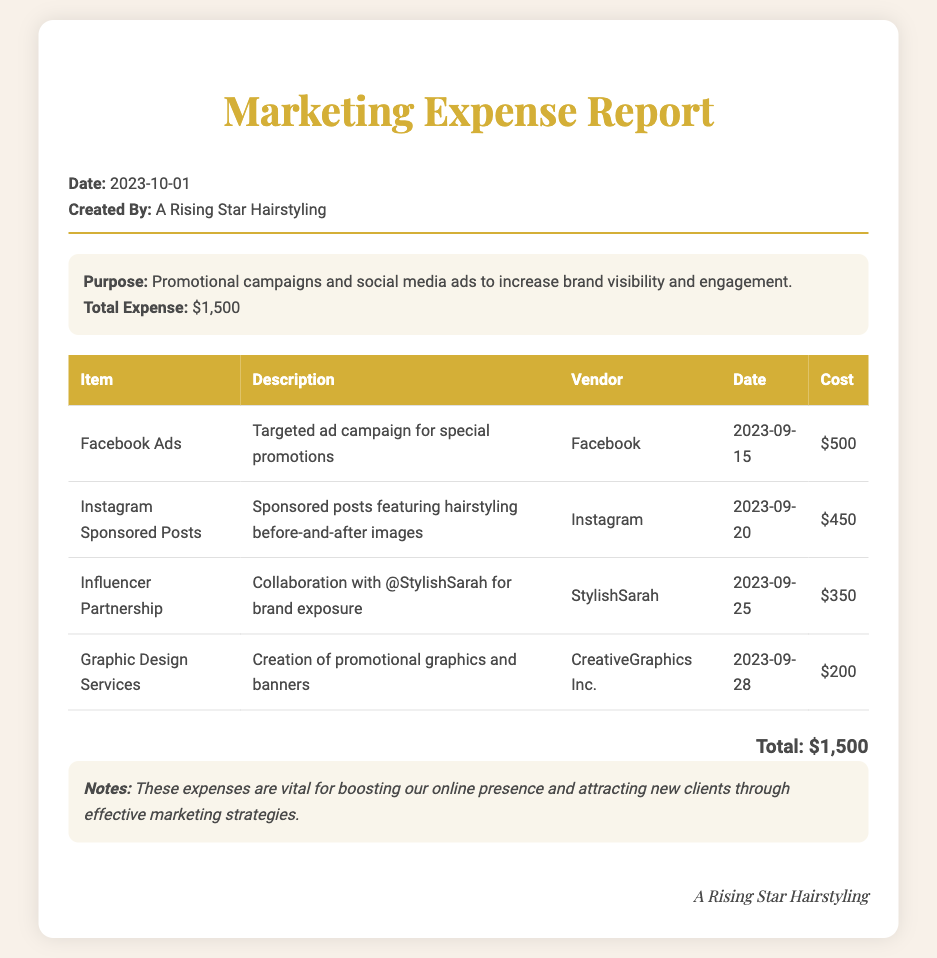What is the total expense? The total expense is listed in the summary section as $1,500.
Answer: $1,500 Who created the report? The report is created by A Rising Star Hairstyling as stated at the top of the document.
Answer: A Rising Star Hairstyling What was the purpose of the expenses? The purpose is stated in the summary section, which mentions promotional campaigns and social media ads.
Answer: Promotional campaigns and social media ads What is the cost of the Facebook Ads? The specific cost for the Facebook Ads is detailed in the table as $500.
Answer: $500 Which vendor was involved in the Influencer Partnership? The vendor for the Influencer Partnership is given as StylishSarah in the expense table.
Answer: StylishSarah How many promotional items are listed in the report? The report lists four promotional items in the expense table, indicating the variety of campaigns.
Answer: 4 When was the Instagram Sponsored Posts expense incurred? The date for the Instagram Sponsored Posts appears in the table as 2023-09-20.
Answer: 2023-09-20 What type of service was provided by CreativeGraphics Inc.? The document specifies that CreativeGraphics Inc. provided graphic design services for promotional materials.
Answer: Graphic design services What is the description of the Influencer Partnership? The description in the table specifies that it was a collaboration with @StylishSarah for brand exposure.
Answer: Collaboration with @StylishSarah for brand exposure 